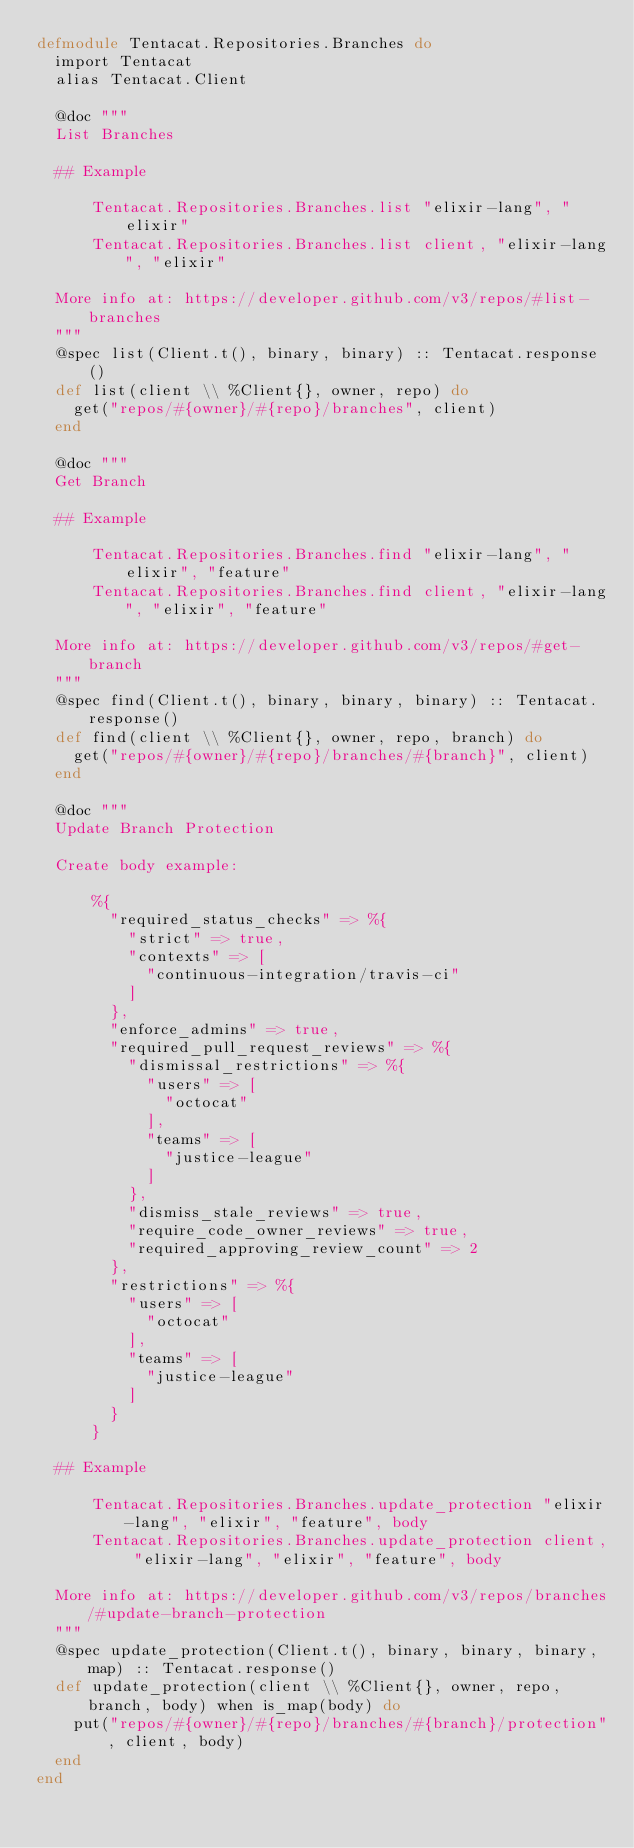<code> <loc_0><loc_0><loc_500><loc_500><_Elixir_>defmodule Tentacat.Repositories.Branches do
  import Tentacat
  alias Tentacat.Client

  @doc """
  List Branches

  ## Example

      Tentacat.Repositories.Branches.list "elixir-lang", "elixir"
      Tentacat.Repositories.Branches.list client, "elixir-lang", "elixir"

  More info at: https://developer.github.com/v3/repos/#list-branches
  """
  @spec list(Client.t(), binary, binary) :: Tentacat.response()
  def list(client \\ %Client{}, owner, repo) do
    get("repos/#{owner}/#{repo}/branches", client)
  end

  @doc """
  Get Branch

  ## Example

      Tentacat.Repositories.Branches.find "elixir-lang", "elixir", "feature"
      Tentacat.Repositories.Branches.find client, "elixir-lang", "elixir", "feature"

  More info at: https://developer.github.com/v3/repos/#get-branch
  """
  @spec find(Client.t(), binary, binary, binary) :: Tentacat.response()
  def find(client \\ %Client{}, owner, repo, branch) do
    get("repos/#{owner}/#{repo}/branches/#{branch}", client)
  end

  @doc """
  Update Branch Protection

  Create body example:

      %{
        "required_status_checks" => %{
          "strict" => true,
          "contexts" => [
            "continuous-integration/travis-ci"
          ]
        },
        "enforce_admins" => true,
        "required_pull_request_reviews" => %{
          "dismissal_restrictions" => %{
            "users" => [
              "octocat"
            ],
            "teams" => [
              "justice-league"
            ]
          },
          "dismiss_stale_reviews" => true,
          "require_code_owner_reviews" => true,
          "required_approving_review_count" => 2
        },
        "restrictions" => %{
          "users" => [
            "octocat"
          ],
          "teams" => [
            "justice-league"
          ]
        }
      }

  ## Example

      Tentacat.Repositories.Branches.update_protection "elixir-lang", "elixir", "feature", body
      Tentacat.Repositories.Branches.update_protection client, "elixir-lang", "elixir", "feature", body

  More info at: https://developer.github.com/v3/repos/branches/#update-branch-protection
  """
  @spec update_protection(Client.t(), binary, binary, binary, map) :: Tentacat.response()
  def update_protection(client \\ %Client{}, owner, repo, branch, body) when is_map(body) do
    put("repos/#{owner}/#{repo}/branches/#{branch}/protection", client, body)
  end
end
</code> 